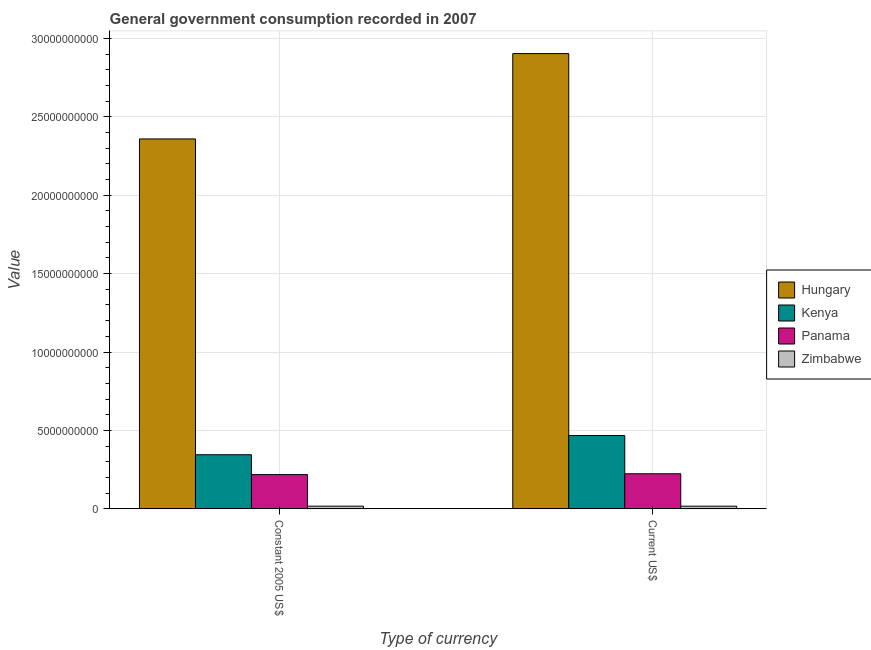Are the number of bars on each tick of the X-axis equal?
Provide a short and direct response. Yes. How many bars are there on the 2nd tick from the right?
Provide a succinct answer. 4. What is the label of the 1st group of bars from the left?
Offer a terse response. Constant 2005 US$. What is the value consumed in constant 2005 us$ in Panama?
Give a very brief answer. 2.18e+09. Across all countries, what is the maximum value consumed in current us$?
Offer a very short reply. 2.90e+1. Across all countries, what is the minimum value consumed in constant 2005 us$?
Give a very brief answer. 1.72e+08. In which country was the value consumed in current us$ maximum?
Make the answer very short. Hungary. In which country was the value consumed in constant 2005 us$ minimum?
Provide a short and direct response. Zimbabwe. What is the total value consumed in constant 2005 us$ in the graph?
Give a very brief answer. 2.94e+1. What is the difference between the value consumed in constant 2005 us$ in Hungary and that in Panama?
Provide a succinct answer. 2.14e+1. What is the difference between the value consumed in current us$ in Panama and the value consumed in constant 2005 us$ in Hungary?
Your answer should be very brief. -2.14e+1. What is the average value consumed in constant 2005 us$ per country?
Offer a terse response. 7.35e+09. What is the difference between the value consumed in constant 2005 us$ and value consumed in current us$ in Hungary?
Your answer should be very brief. -5.44e+09. In how many countries, is the value consumed in constant 2005 us$ greater than 2000000000 ?
Ensure brevity in your answer.  3. What is the ratio of the value consumed in constant 2005 us$ in Zimbabwe to that in Hungary?
Your answer should be very brief. 0.01. In how many countries, is the value consumed in current us$ greater than the average value consumed in current us$ taken over all countries?
Ensure brevity in your answer.  1. What does the 4th bar from the left in Constant 2005 US$ represents?
Your answer should be compact. Zimbabwe. What does the 1st bar from the right in Current US$ represents?
Keep it short and to the point. Zimbabwe. Are all the bars in the graph horizontal?
Ensure brevity in your answer.  No. Does the graph contain any zero values?
Your answer should be very brief. No. Where does the legend appear in the graph?
Your answer should be very brief. Center right. How many legend labels are there?
Your response must be concise. 4. What is the title of the graph?
Offer a very short reply. General government consumption recorded in 2007. Does "World" appear as one of the legend labels in the graph?
Ensure brevity in your answer.  No. What is the label or title of the X-axis?
Provide a short and direct response. Type of currency. What is the label or title of the Y-axis?
Your answer should be very brief. Value. What is the Value of Hungary in Constant 2005 US$?
Make the answer very short. 2.36e+1. What is the Value of Kenya in Constant 2005 US$?
Make the answer very short. 3.45e+09. What is the Value of Panama in Constant 2005 US$?
Your response must be concise. 2.18e+09. What is the Value of Zimbabwe in Constant 2005 US$?
Make the answer very short. 1.72e+08. What is the Value of Hungary in Current US$?
Offer a terse response. 2.90e+1. What is the Value of Kenya in Current US$?
Give a very brief answer. 4.68e+09. What is the Value in Panama in Current US$?
Your answer should be compact. 2.24e+09. What is the Value of Zimbabwe in Current US$?
Your answer should be very brief. 1.70e+08. Across all Type of currency, what is the maximum Value of Hungary?
Offer a very short reply. 2.90e+1. Across all Type of currency, what is the maximum Value of Kenya?
Offer a terse response. 4.68e+09. Across all Type of currency, what is the maximum Value of Panama?
Your answer should be very brief. 2.24e+09. Across all Type of currency, what is the maximum Value in Zimbabwe?
Your answer should be compact. 1.72e+08. Across all Type of currency, what is the minimum Value in Hungary?
Make the answer very short. 2.36e+1. Across all Type of currency, what is the minimum Value of Kenya?
Offer a terse response. 3.45e+09. Across all Type of currency, what is the minimum Value in Panama?
Ensure brevity in your answer.  2.18e+09. Across all Type of currency, what is the minimum Value of Zimbabwe?
Provide a short and direct response. 1.70e+08. What is the total Value of Hungary in the graph?
Ensure brevity in your answer.  5.26e+1. What is the total Value in Kenya in the graph?
Make the answer very short. 8.13e+09. What is the total Value of Panama in the graph?
Make the answer very short. 4.42e+09. What is the total Value in Zimbabwe in the graph?
Ensure brevity in your answer.  3.42e+08. What is the difference between the Value of Hungary in Constant 2005 US$ and that in Current US$?
Offer a terse response. -5.44e+09. What is the difference between the Value in Kenya in Constant 2005 US$ and that in Current US$?
Give a very brief answer. -1.22e+09. What is the difference between the Value of Panama in Constant 2005 US$ and that in Current US$?
Your answer should be very brief. -5.36e+07. What is the difference between the Value in Zimbabwe in Constant 2005 US$ and that in Current US$?
Ensure brevity in your answer.  1.99e+06. What is the difference between the Value of Hungary in Constant 2005 US$ and the Value of Kenya in Current US$?
Keep it short and to the point. 1.89e+1. What is the difference between the Value of Hungary in Constant 2005 US$ and the Value of Panama in Current US$?
Provide a short and direct response. 2.14e+1. What is the difference between the Value of Hungary in Constant 2005 US$ and the Value of Zimbabwe in Current US$?
Give a very brief answer. 2.34e+1. What is the difference between the Value of Kenya in Constant 2005 US$ and the Value of Panama in Current US$?
Offer a terse response. 1.21e+09. What is the difference between the Value of Kenya in Constant 2005 US$ and the Value of Zimbabwe in Current US$?
Give a very brief answer. 3.28e+09. What is the difference between the Value in Panama in Constant 2005 US$ and the Value in Zimbabwe in Current US$?
Your answer should be very brief. 2.01e+09. What is the average Value in Hungary per Type of currency?
Your response must be concise. 2.63e+1. What is the average Value of Kenya per Type of currency?
Your answer should be very brief. 4.06e+09. What is the average Value of Panama per Type of currency?
Give a very brief answer. 2.21e+09. What is the average Value of Zimbabwe per Type of currency?
Give a very brief answer. 1.71e+08. What is the difference between the Value of Hungary and Value of Kenya in Constant 2005 US$?
Ensure brevity in your answer.  2.01e+1. What is the difference between the Value of Hungary and Value of Panama in Constant 2005 US$?
Keep it short and to the point. 2.14e+1. What is the difference between the Value in Hungary and Value in Zimbabwe in Constant 2005 US$?
Offer a terse response. 2.34e+1. What is the difference between the Value in Kenya and Value in Panama in Constant 2005 US$?
Ensure brevity in your answer.  1.27e+09. What is the difference between the Value of Kenya and Value of Zimbabwe in Constant 2005 US$?
Offer a very short reply. 3.28e+09. What is the difference between the Value of Panama and Value of Zimbabwe in Constant 2005 US$?
Make the answer very short. 2.01e+09. What is the difference between the Value of Hungary and Value of Kenya in Current US$?
Keep it short and to the point. 2.44e+1. What is the difference between the Value of Hungary and Value of Panama in Current US$?
Provide a short and direct response. 2.68e+1. What is the difference between the Value of Hungary and Value of Zimbabwe in Current US$?
Ensure brevity in your answer.  2.89e+1. What is the difference between the Value in Kenya and Value in Panama in Current US$?
Ensure brevity in your answer.  2.44e+09. What is the difference between the Value in Kenya and Value in Zimbabwe in Current US$?
Give a very brief answer. 4.51e+09. What is the difference between the Value in Panama and Value in Zimbabwe in Current US$?
Provide a succinct answer. 2.07e+09. What is the ratio of the Value in Hungary in Constant 2005 US$ to that in Current US$?
Offer a very short reply. 0.81. What is the ratio of the Value in Kenya in Constant 2005 US$ to that in Current US$?
Offer a terse response. 0.74. What is the ratio of the Value of Panama in Constant 2005 US$ to that in Current US$?
Your answer should be compact. 0.98. What is the ratio of the Value in Zimbabwe in Constant 2005 US$ to that in Current US$?
Offer a very short reply. 1.01. What is the difference between the highest and the second highest Value of Hungary?
Your response must be concise. 5.44e+09. What is the difference between the highest and the second highest Value of Kenya?
Provide a succinct answer. 1.22e+09. What is the difference between the highest and the second highest Value of Panama?
Your answer should be compact. 5.36e+07. What is the difference between the highest and the second highest Value in Zimbabwe?
Ensure brevity in your answer.  1.99e+06. What is the difference between the highest and the lowest Value of Hungary?
Offer a very short reply. 5.44e+09. What is the difference between the highest and the lowest Value in Kenya?
Provide a short and direct response. 1.22e+09. What is the difference between the highest and the lowest Value of Panama?
Offer a terse response. 5.36e+07. What is the difference between the highest and the lowest Value of Zimbabwe?
Offer a terse response. 1.99e+06. 